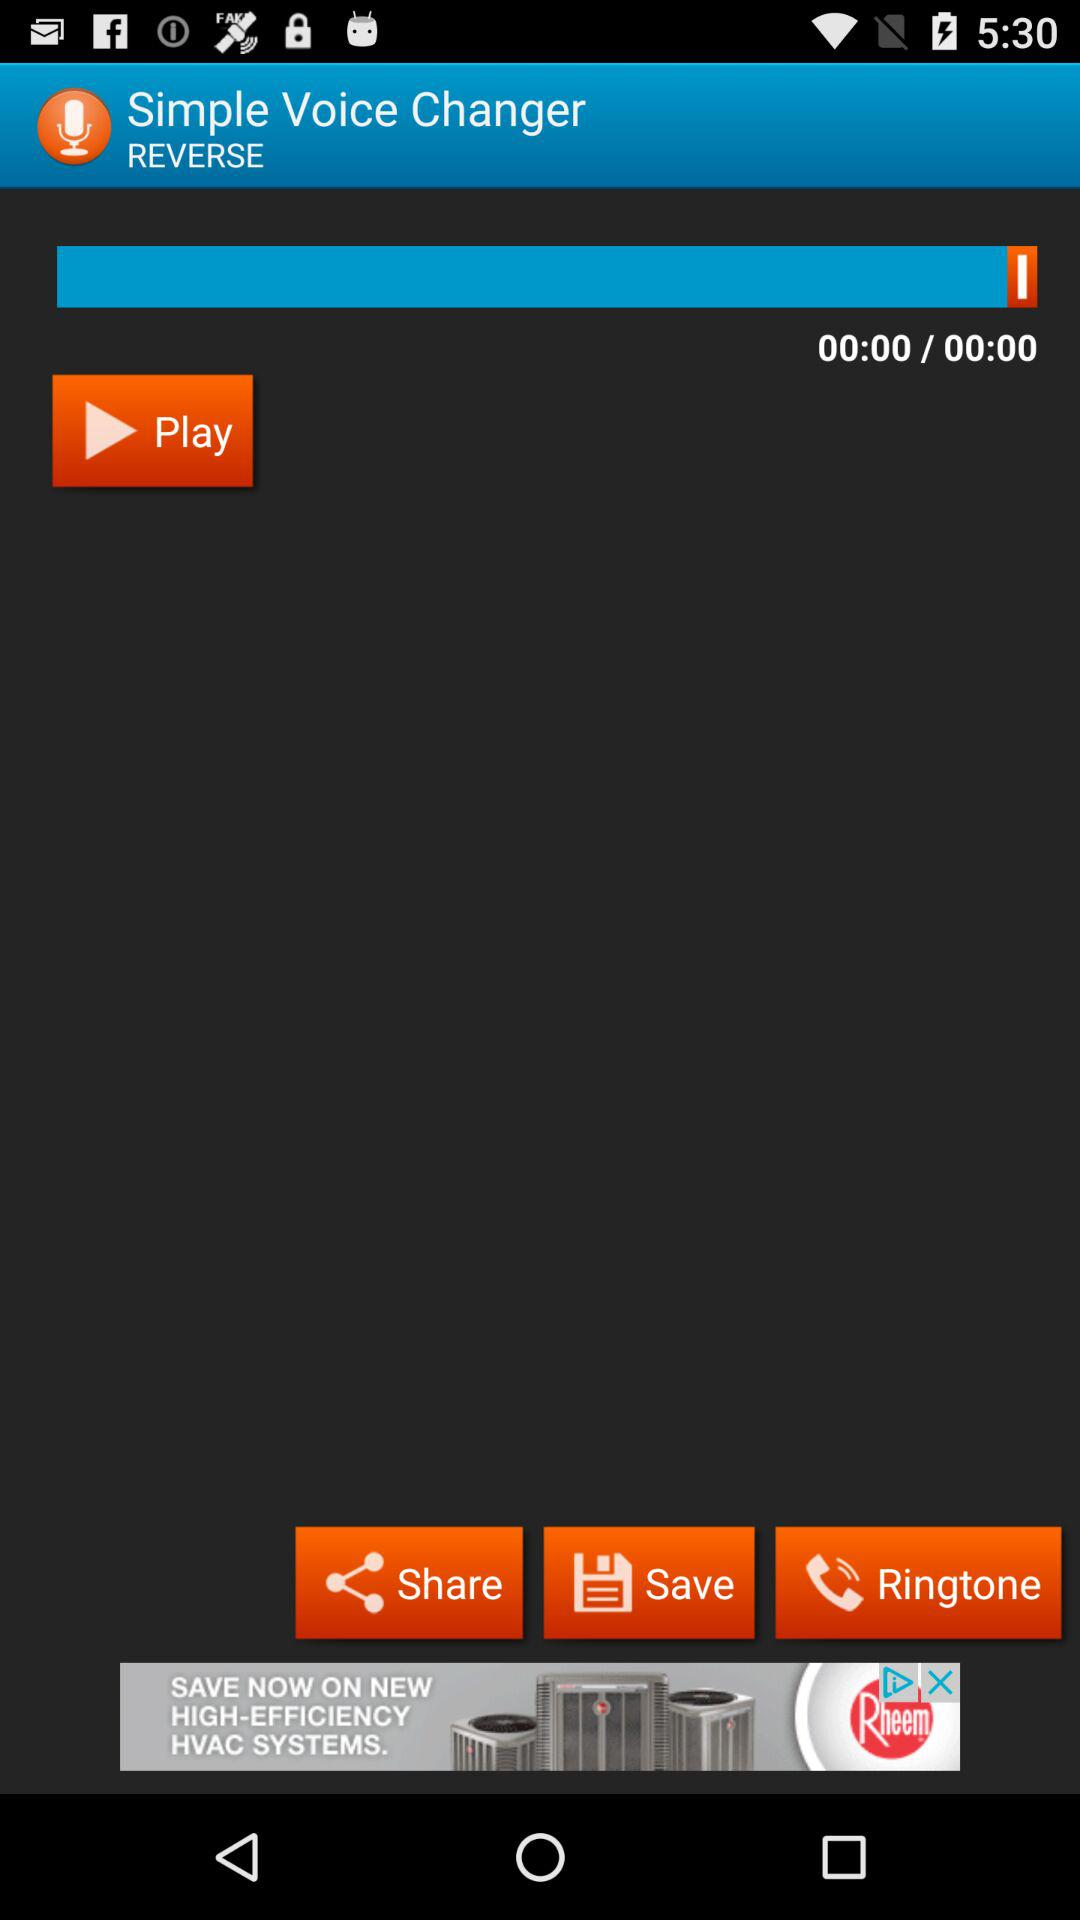To which file can the audio be saved?
When the provided information is insufficient, respond with <no answer>. <no answer> 